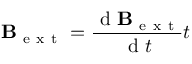Convert formula to latex. <formula><loc_0><loc_0><loc_500><loc_500>B _ { e x t } = \frac { d B _ { e x t } } { d t } t</formula> 